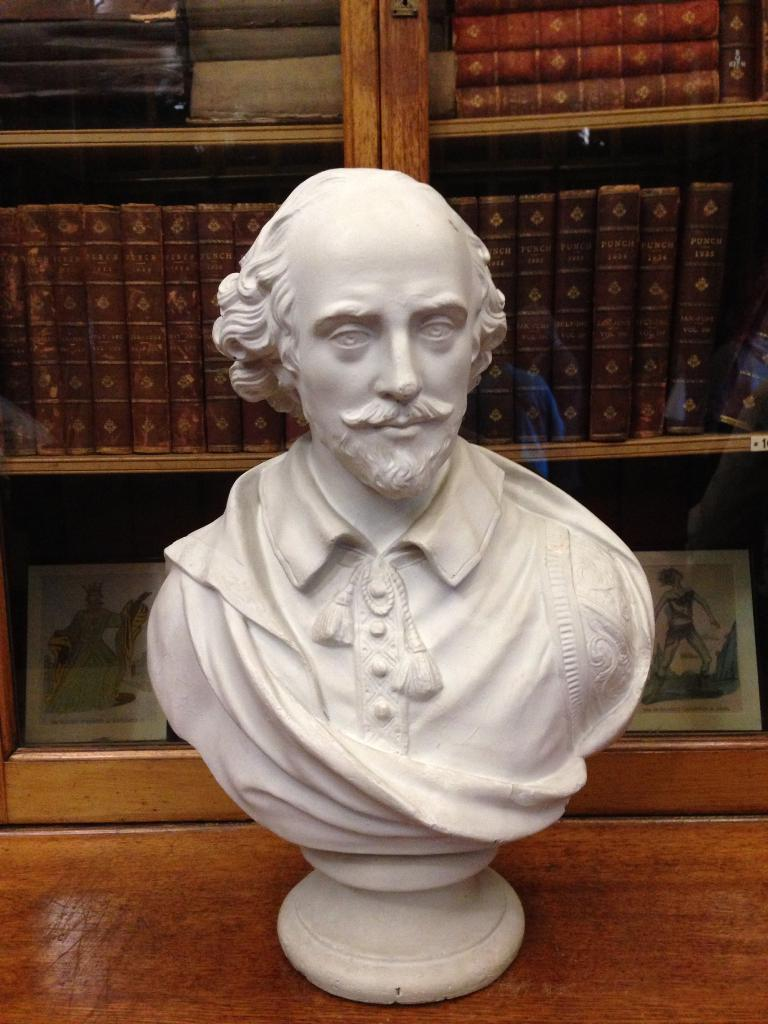What is the main subject of the image? There is a bust of a man in the image. Where is the bust located? The bust is placed on a desk. What can be seen in the background of the image? There is a cupboard in the background of the image. What is stored in the cupboard? Books are placed in the cupboard. How many balls are visible on the desk with the bust? There are no balls visible on the desk with the bust; the image only features the bust and a cupboard in the background. 